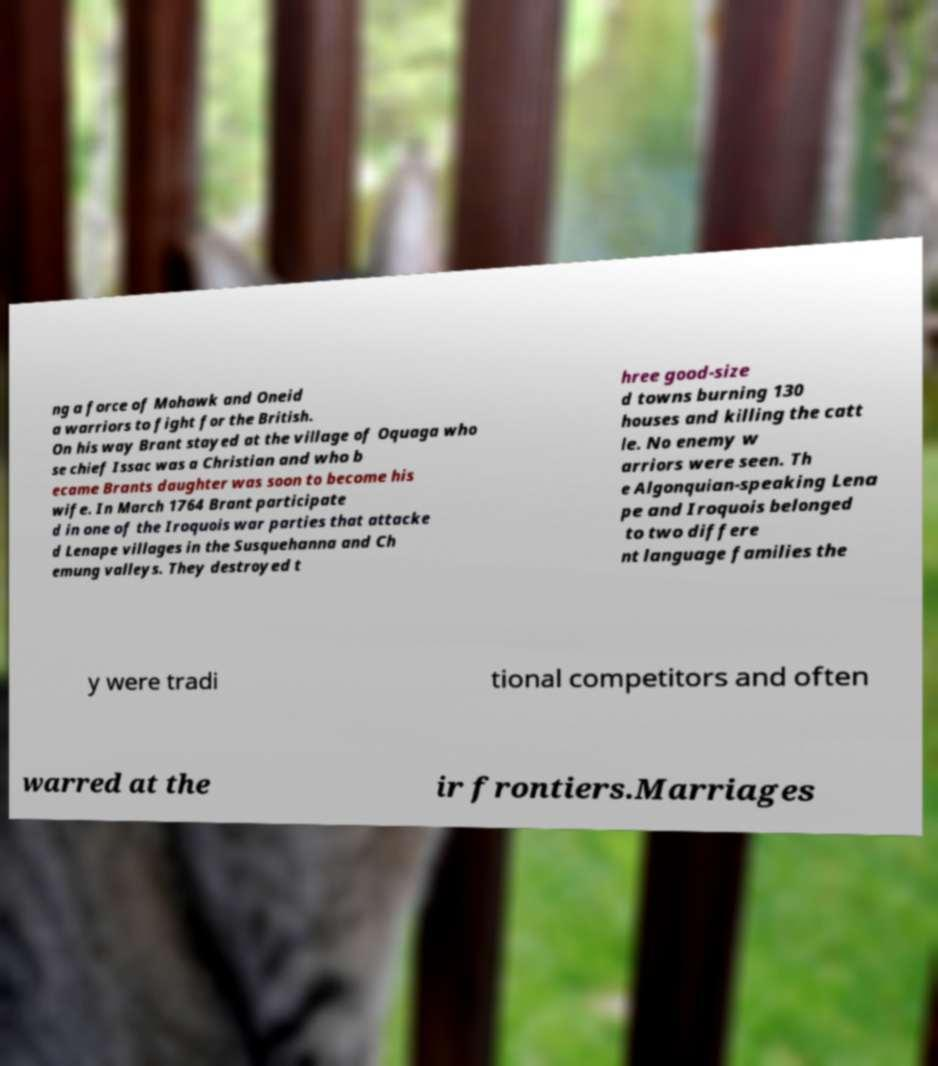There's text embedded in this image that I need extracted. Can you transcribe it verbatim? ng a force of Mohawk and Oneid a warriors to fight for the British. On his way Brant stayed at the village of Oquaga who se chief Issac was a Christian and who b ecame Brants daughter was soon to become his wife. In March 1764 Brant participate d in one of the Iroquois war parties that attacke d Lenape villages in the Susquehanna and Ch emung valleys. They destroyed t hree good-size d towns burning 130 houses and killing the catt le. No enemy w arriors were seen. Th e Algonquian-speaking Lena pe and Iroquois belonged to two differe nt language families the y were tradi tional competitors and often warred at the ir frontiers.Marriages 